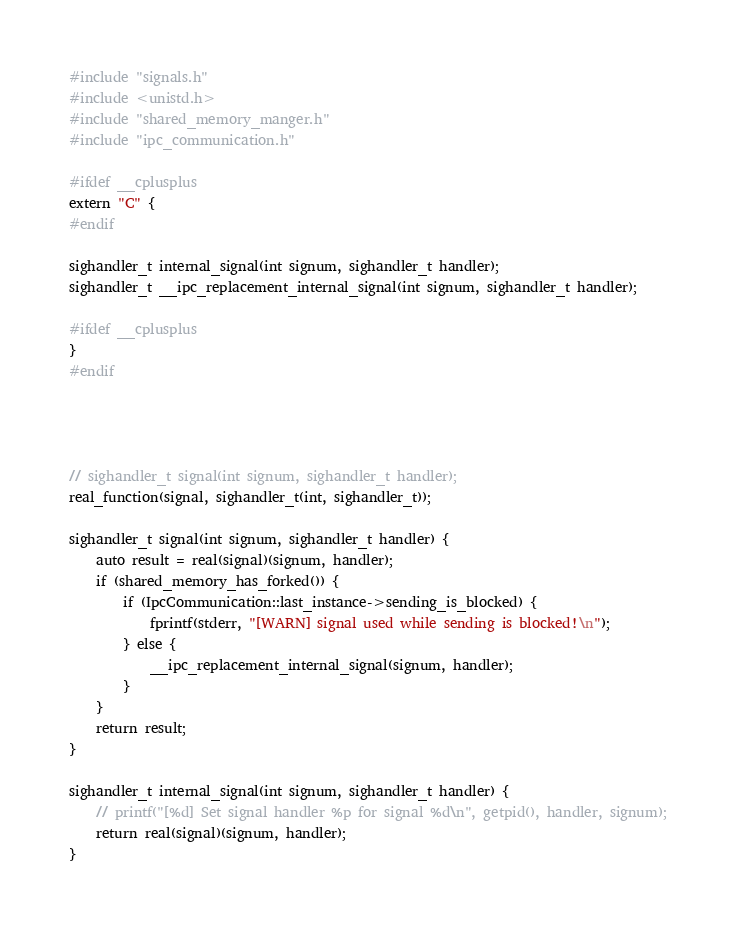<code> <loc_0><loc_0><loc_500><loc_500><_C++_>#include "signals.h"
#include <unistd.h>
#include "shared_memory_manger.h"
#include "ipc_communication.h"

#ifdef __cplusplus
extern "C" {
#endif

sighandler_t internal_signal(int signum, sighandler_t handler);
sighandler_t __ipc_replacement_internal_signal(int signum, sighandler_t handler);

#ifdef __cplusplus
}
#endif




// sighandler_t signal(int signum, sighandler_t handler);
real_function(signal, sighandler_t(int, sighandler_t));

sighandler_t signal(int signum, sighandler_t handler) {
	auto result = real(signal)(signum, handler);
	if (shared_memory_has_forked()) {
		if (IpcCommunication::last_instance->sending_is_blocked) {
			fprintf(stderr, "[WARN] signal used while sending is blocked!\n");
		} else {
			__ipc_replacement_internal_signal(signum, handler);
		}
	}
	return result;
}

sighandler_t internal_signal(int signum, sighandler_t handler) {
	// printf("[%d] Set signal handler %p for signal %d\n", getpid(), handler, signum);
	return real(signal)(signum, handler);
}

</code> 